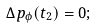Convert formula to latex. <formula><loc_0><loc_0><loc_500><loc_500>\Delta p _ { \phi } ( t _ { 2 } ) = 0 ;</formula> 